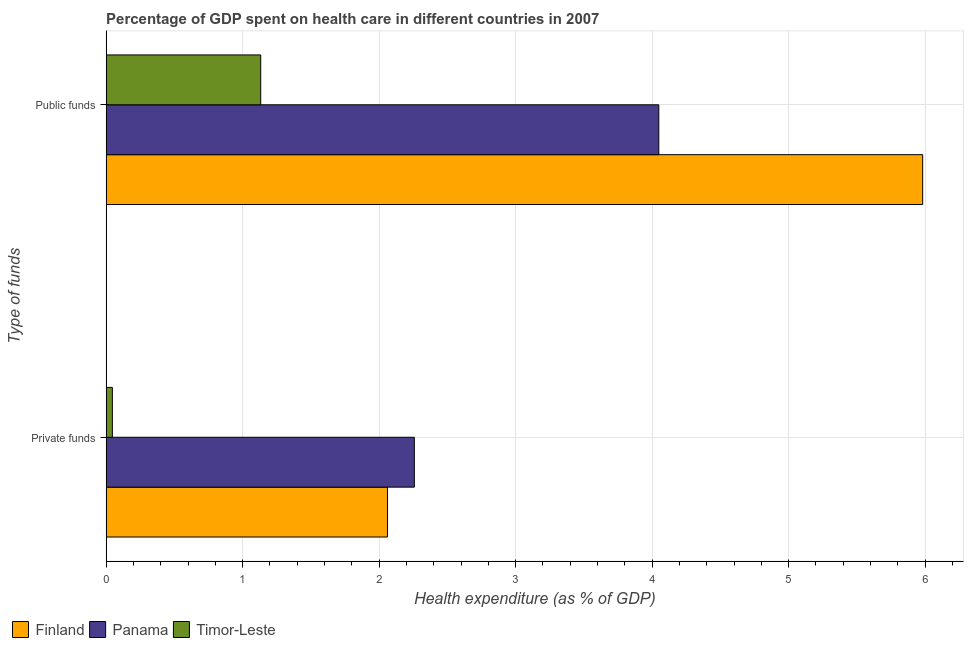How many different coloured bars are there?
Ensure brevity in your answer.  3. Are the number of bars per tick equal to the number of legend labels?
Ensure brevity in your answer.  Yes. Are the number of bars on each tick of the Y-axis equal?
Your response must be concise. Yes. What is the label of the 1st group of bars from the top?
Offer a very short reply. Public funds. What is the amount of public funds spent in healthcare in Timor-Leste?
Provide a short and direct response. 1.13. Across all countries, what is the maximum amount of private funds spent in healthcare?
Offer a terse response. 2.26. Across all countries, what is the minimum amount of public funds spent in healthcare?
Provide a succinct answer. 1.13. In which country was the amount of private funds spent in healthcare maximum?
Your response must be concise. Panama. In which country was the amount of private funds spent in healthcare minimum?
Ensure brevity in your answer.  Timor-Leste. What is the total amount of public funds spent in healthcare in the graph?
Make the answer very short. 11.16. What is the difference between the amount of public funds spent in healthcare in Panama and that in Finland?
Provide a short and direct response. -1.93. What is the difference between the amount of private funds spent in healthcare in Timor-Leste and the amount of public funds spent in healthcare in Finland?
Provide a short and direct response. -5.94. What is the average amount of public funds spent in healthcare per country?
Ensure brevity in your answer.  3.72. What is the difference between the amount of private funds spent in healthcare and amount of public funds spent in healthcare in Finland?
Make the answer very short. -3.92. In how many countries, is the amount of public funds spent in healthcare greater than 1.6 %?
Give a very brief answer. 2. What is the ratio of the amount of public funds spent in healthcare in Finland to that in Timor-Leste?
Provide a succinct answer. 5.28. In how many countries, is the amount of public funds spent in healthcare greater than the average amount of public funds spent in healthcare taken over all countries?
Offer a very short reply. 2. What does the 2nd bar from the top in Public funds represents?
Provide a succinct answer. Panama. What does the 2nd bar from the bottom in Private funds represents?
Offer a terse response. Panama. How many bars are there?
Provide a short and direct response. 6. Are all the bars in the graph horizontal?
Make the answer very short. Yes. How many countries are there in the graph?
Keep it short and to the point. 3. Does the graph contain any zero values?
Offer a very short reply. No. Does the graph contain grids?
Offer a very short reply. Yes. How many legend labels are there?
Make the answer very short. 3. How are the legend labels stacked?
Provide a succinct answer. Horizontal. What is the title of the graph?
Make the answer very short. Percentage of GDP spent on health care in different countries in 2007. Does "Dominica" appear as one of the legend labels in the graph?
Provide a succinct answer. No. What is the label or title of the X-axis?
Ensure brevity in your answer.  Health expenditure (as % of GDP). What is the label or title of the Y-axis?
Offer a very short reply. Type of funds. What is the Health expenditure (as % of GDP) of Finland in Private funds?
Offer a very short reply. 2.06. What is the Health expenditure (as % of GDP) in Panama in Private funds?
Ensure brevity in your answer.  2.26. What is the Health expenditure (as % of GDP) in Timor-Leste in Private funds?
Provide a succinct answer. 0.05. What is the Health expenditure (as % of GDP) in Finland in Public funds?
Offer a terse response. 5.98. What is the Health expenditure (as % of GDP) of Panama in Public funds?
Make the answer very short. 4.05. What is the Health expenditure (as % of GDP) of Timor-Leste in Public funds?
Ensure brevity in your answer.  1.13. Across all Type of funds, what is the maximum Health expenditure (as % of GDP) in Finland?
Provide a short and direct response. 5.98. Across all Type of funds, what is the maximum Health expenditure (as % of GDP) of Panama?
Ensure brevity in your answer.  4.05. Across all Type of funds, what is the maximum Health expenditure (as % of GDP) in Timor-Leste?
Provide a succinct answer. 1.13. Across all Type of funds, what is the minimum Health expenditure (as % of GDP) in Finland?
Give a very brief answer. 2.06. Across all Type of funds, what is the minimum Health expenditure (as % of GDP) of Panama?
Make the answer very short. 2.26. Across all Type of funds, what is the minimum Health expenditure (as % of GDP) in Timor-Leste?
Ensure brevity in your answer.  0.05. What is the total Health expenditure (as % of GDP) in Finland in the graph?
Ensure brevity in your answer.  8.04. What is the total Health expenditure (as % of GDP) in Panama in the graph?
Offer a very short reply. 6.31. What is the total Health expenditure (as % of GDP) of Timor-Leste in the graph?
Offer a very short reply. 1.18. What is the difference between the Health expenditure (as % of GDP) of Finland in Private funds and that in Public funds?
Provide a succinct answer. -3.92. What is the difference between the Health expenditure (as % of GDP) in Panama in Private funds and that in Public funds?
Your answer should be compact. -1.79. What is the difference between the Health expenditure (as % of GDP) in Timor-Leste in Private funds and that in Public funds?
Keep it short and to the point. -1.09. What is the difference between the Health expenditure (as % of GDP) of Finland in Private funds and the Health expenditure (as % of GDP) of Panama in Public funds?
Keep it short and to the point. -1.99. What is the difference between the Health expenditure (as % of GDP) in Finland in Private funds and the Health expenditure (as % of GDP) in Timor-Leste in Public funds?
Provide a short and direct response. 0.93. What is the difference between the Health expenditure (as % of GDP) in Panama in Private funds and the Health expenditure (as % of GDP) in Timor-Leste in Public funds?
Offer a very short reply. 1.13. What is the average Health expenditure (as % of GDP) in Finland per Type of funds?
Ensure brevity in your answer.  4.02. What is the average Health expenditure (as % of GDP) in Panama per Type of funds?
Your answer should be compact. 3.15. What is the average Health expenditure (as % of GDP) of Timor-Leste per Type of funds?
Provide a succinct answer. 0.59. What is the difference between the Health expenditure (as % of GDP) of Finland and Health expenditure (as % of GDP) of Panama in Private funds?
Ensure brevity in your answer.  -0.2. What is the difference between the Health expenditure (as % of GDP) of Finland and Health expenditure (as % of GDP) of Timor-Leste in Private funds?
Ensure brevity in your answer.  2.02. What is the difference between the Health expenditure (as % of GDP) in Panama and Health expenditure (as % of GDP) in Timor-Leste in Private funds?
Ensure brevity in your answer.  2.21. What is the difference between the Health expenditure (as % of GDP) of Finland and Health expenditure (as % of GDP) of Panama in Public funds?
Your answer should be very brief. 1.93. What is the difference between the Health expenditure (as % of GDP) in Finland and Health expenditure (as % of GDP) in Timor-Leste in Public funds?
Keep it short and to the point. 4.85. What is the difference between the Health expenditure (as % of GDP) in Panama and Health expenditure (as % of GDP) in Timor-Leste in Public funds?
Offer a very short reply. 2.92. What is the ratio of the Health expenditure (as % of GDP) in Finland in Private funds to that in Public funds?
Your answer should be very brief. 0.34. What is the ratio of the Health expenditure (as % of GDP) in Panama in Private funds to that in Public funds?
Your answer should be very brief. 0.56. What is the ratio of the Health expenditure (as % of GDP) of Timor-Leste in Private funds to that in Public funds?
Ensure brevity in your answer.  0.04. What is the difference between the highest and the second highest Health expenditure (as % of GDP) in Finland?
Provide a short and direct response. 3.92. What is the difference between the highest and the second highest Health expenditure (as % of GDP) in Panama?
Your answer should be compact. 1.79. What is the difference between the highest and the second highest Health expenditure (as % of GDP) of Timor-Leste?
Provide a short and direct response. 1.09. What is the difference between the highest and the lowest Health expenditure (as % of GDP) of Finland?
Provide a short and direct response. 3.92. What is the difference between the highest and the lowest Health expenditure (as % of GDP) of Panama?
Your response must be concise. 1.79. What is the difference between the highest and the lowest Health expenditure (as % of GDP) in Timor-Leste?
Keep it short and to the point. 1.09. 